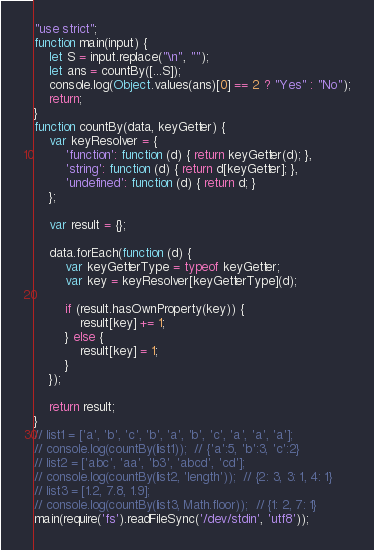Convert code to text. <code><loc_0><loc_0><loc_500><loc_500><_JavaScript_>"use strict";
function main(input) {
    let S = input.replace("\n", "");
    let ans = countBy([...S]);
    console.log(Object.values(ans)[0] == 2 ? "Yes" : "No");
    return;
}
function countBy(data, keyGetter) {
    var keyResolver = {
        'function': function (d) { return keyGetter(d); },
        'string': function (d) { return d[keyGetter]; },
        'undefined': function (d) { return d; }
    };

    var result = {};

    data.forEach(function (d) {
        var keyGetterType = typeof keyGetter;
        var key = keyResolver[keyGetterType](d);

        if (result.hasOwnProperty(key)) {
            result[key] += 1;
        } else {
            result[key] = 1;
        }
    });

    return result;
}
// list1 = ['a', 'b', 'c', 'b', 'a', 'b', 'c', 'a', 'a', 'a'];
// console.log(countBy(list1));  // {'a':5, 'b':3, 'c':2}
// list2 = ['abc', 'aa', 'b3', 'abcd', 'cd'];
// console.log(countBy(list2, 'length'));  // {2: 3, 3: 1, 4: 1}
// list3 = [1.2, 7.8, 1.9];
// console.log(countBy(list3, Math.floor));  // {1: 2, 7: 1}
main(require('fs').readFileSync('/dev/stdin', 'utf8'));</code> 